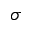<formula> <loc_0><loc_0><loc_500><loc_500>\sigma</formula> 